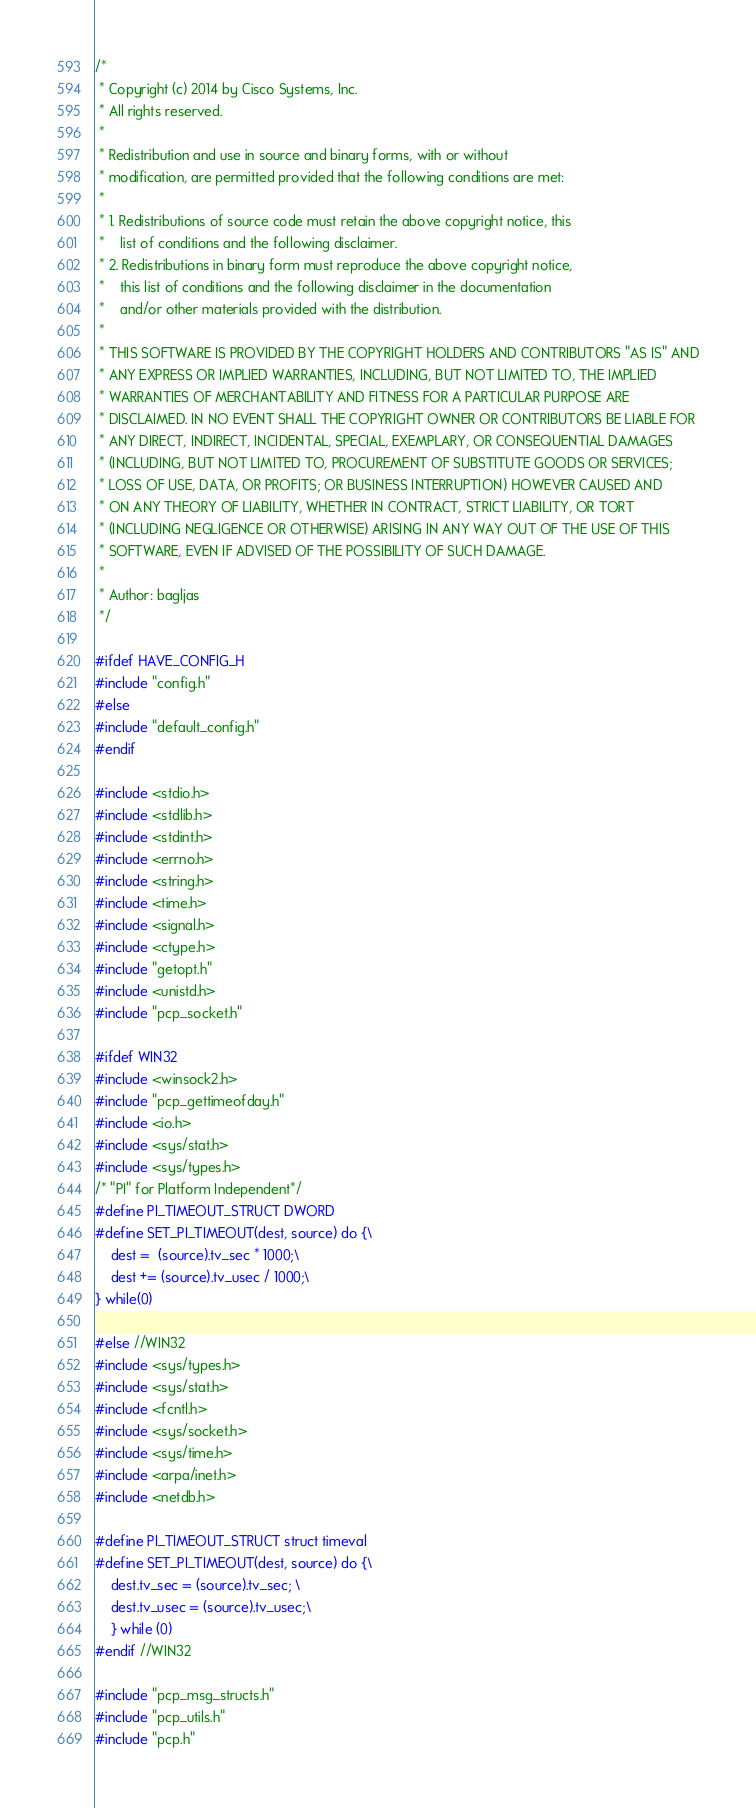Convert code to text. <code><loc_0><loc_0><loc_500><loc_500><_C_>/*
 * Copyright (c) 2014 by Cisco Systems, Inc.
 * All rights reserved.
 *
 * Redistribution and use in source and binary forms, with or without
 * modification, are permitted provided that the following conditions are met:
 *
 * 1. Redistributions of source code must retain the above copyright notice, this
 *    list of conditions and the following disclaimer.
 * 2. Redistributions in binary form must reproduce the above copyright notice,
 *    this list of conditions and the following disclaimer in the documentation
 *    and/or other materials provided with the distribution.
 *
 * THIS SOFTWARE IS PROVIDED BY THE COPYRIGHT HOLDERS AND CONTRIBUTORS "AS IS" AND
 * ANY EXPRESS OR IMPLIED WARRANTIES, INCLUDING, BUT NOT LIMITED TO, THE IMPLIED
 * WARRANTIES OF MERCHANTABILITY AND FITNESS FOR A PARTICULAR PURPOSE ARE
 * DISCLAIMED. IN NO EVENT SHALL THE COPYRIGHT OWNER OR CONTRIBUTORS BE LIABLE FOR
 * ANY DIRECT, INDIRECT, INCIDENTAL, SPECIAL, EXEMPLARY, OR CONSEQUENTIAL DAMAGES
 * (INCLUDING, BUT NOT LIMITED TO, PROCUREMENT OF SUBSTITUTE GOODS OR SERVICES;
 * LOSS OF USE, DATA, OR PROFITS; OR BUSINESS INTERRUPTION) HOWEVER CAUSED AND
 * ON ANY THEORY OF LIABILITY, WHETHER IN CONTRACT, STRICT LIABILITY, OR TORT
 * (INCLUDING NEGLIGENCE OR OTHERWISE) ARISING IN ANY WAY OUT OF THE USE OF THIS
 * SOFTWARE, EVEN IF ADVISED OF THE POSSIBILITY OF SUCH DAMAGE.
 *
 * Author: bagljas
 */

#ifdef HAVE_CONFIG_H
#include "config.h"
#else
#include "default_config.h"
#endif

#include <stdio.h>
#include <stdlib.h>
#include <stdint.h>
#include <errno.h>
#include <string.h>
#include <time.h>
#include <signal.h>
#include <ctype.h>
#include "getopt.h"
#include <unistd.h>
#include "pcp_socket.h"

#ifdef WIN32
#include <winsock2.h>
#include "pcp_gettimeofday.h"
#include <io.h>
#include <sys/stat.h>
#include <sys/types.h>
/* "PI" for Platform Independent*/
#define PI_TIMEOUT_STRUCT DWORD
#define SET_PI_TIMEOUT(dest, source) do {\
    dest =  (source).tv_sec * 1000;\
    dest += (source).tv_usec / 1000;\
} while(0)

#else //WIN32
#include <sys/types.h>
#include <sys/stat.h>
#include <fcntl.h>
#include <sys/socket.h>
#include <sys/time.h>
#include <arpa/inet.h>
#include <netdb.h>

#define PI_TIMEOUT_STRUCT struct timeval
#define SET_PI_TIMEOUT(dest, source) do {\
    dest.tv_sec = (source).tv_sec; \
    dest.tv_usec = (source).tv_usec;\
    } while (0)
#endif //WIN32

#include "pcp_msg_structs.h"
#include "pcp_utils.h"
#include "pcp.h"
</code> 